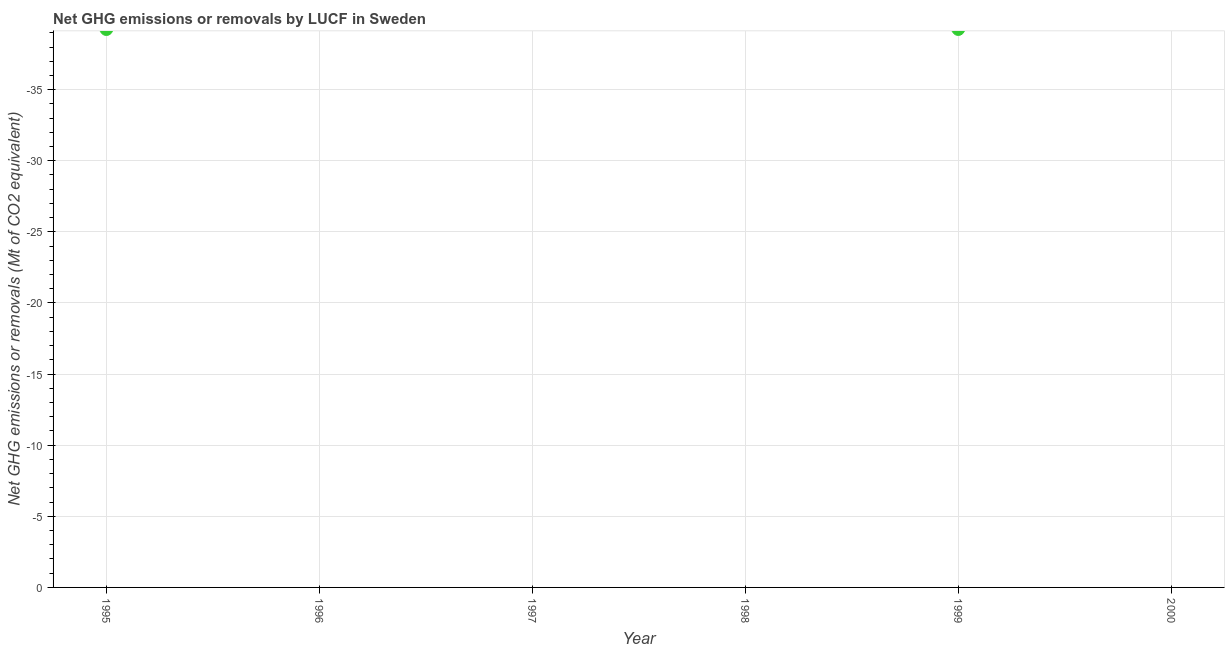In how many years, is the ghg net emissions or removals greater than the average ghg net emissions or removals taken over all years?
Your answer should be compact. 0. Are the values on the major ticks of Y-axis written in scientific E-notation?
Keep it short and to the point. No. Does the graph contain any zero values?
Your answer should be compact. Yes. What is the title of the graph?
Provide a short and direct response. Net GHG emissions or removals by LUCF in Sweden. What is the label or title of the X-axis?
Offer a very short reply. Year. What is the label or title of the Y-axis?
Your response must be concise. Net GHG emissions or removals (Mt of CO2 equivalent). What is the Net GHG emissions or removals (Mt of CO2 equivalent) in 1995?
Your answer should be compact. 0. What is the Net GHG emissions or removals (Mt of CO2 equivalent) in 1996?
Give a very brief answer. 0. What is the Net GHG emissions or removals (Mt of CO2 equivalent) in 1997?
Offer a very short reply. 0. What is the Net GHG emissions or removals (Mt of CO2 equivalent) in 2000?
Your response must be concise. 0. 